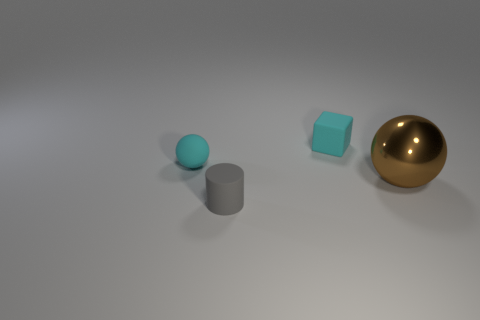Are there any other things that have the same size as the metallic sphere?
Make the answer very short. No. Is the gray object that is to the left of the metal object made of the same material as the large brown thing behind the gray rubber object?
Your answer should be very brief. No. What is the size of the rubber thing behind the tiny object that is on the left side of the gray matte cylinder?
Give a very brief answer. Small. What is the object on the right side of the tiny cube made of?
Provide a short and direct response. Metal. What number of things are objects that are in front of the small cyan ball or big things to the right of the small gray thing?
Offer a terse response. 2. Do the ball behind the large brown metallic sphere and the small thing that is to the right of the small gray rubber object have the same color?
Your response must be concise. Yes. Are there any brown balls of the same size as the cyan matte sphere?
Keep it short and to the point. No. What is the thing that is both to the right of the gray object and in front of the small cyan sphere made of?
Your answer should be compact. Metal. What number of matte things are tiny cyan objects or yellow cylinders?
Provide a succinct answer. 2. What is the shape of the tiny gray thing that is the same material as the small cyan cube?
Make the answer very short. Cylinder. 